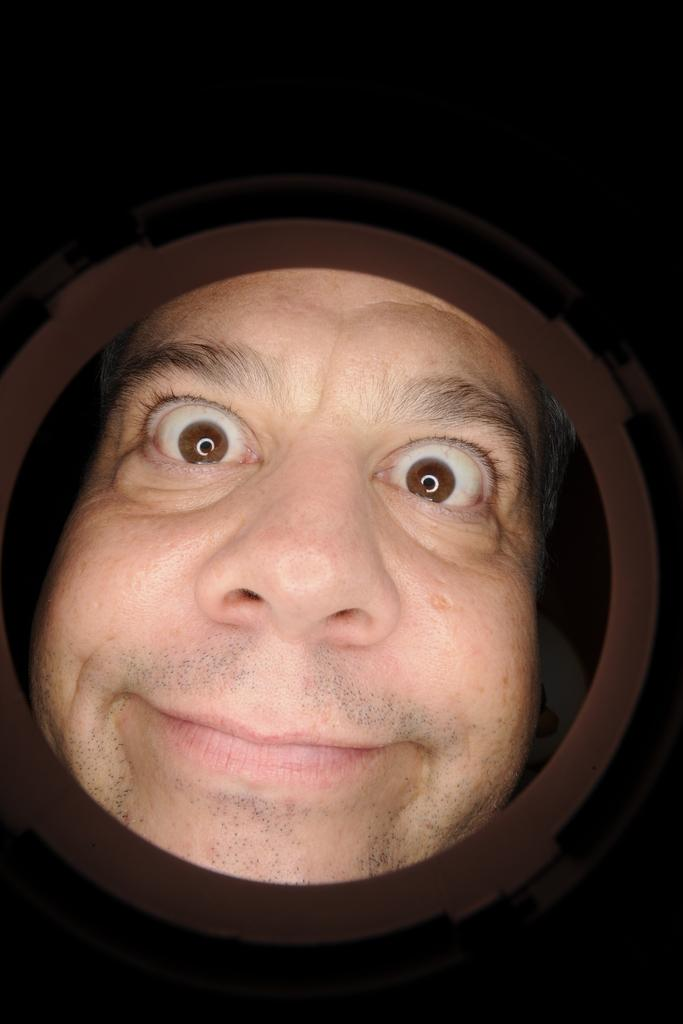What is happening in the image? There is a person in the image who is looking into a hole. How does the person appear in the image? The person's expression is described as weird. What type of turkey can be seen in the image? There is no turkey present in the image; it features a person looking into a hole with a weird expression. What kind of sheet is covering the boundary in the image? There is no sheet or boundary present in the image. 